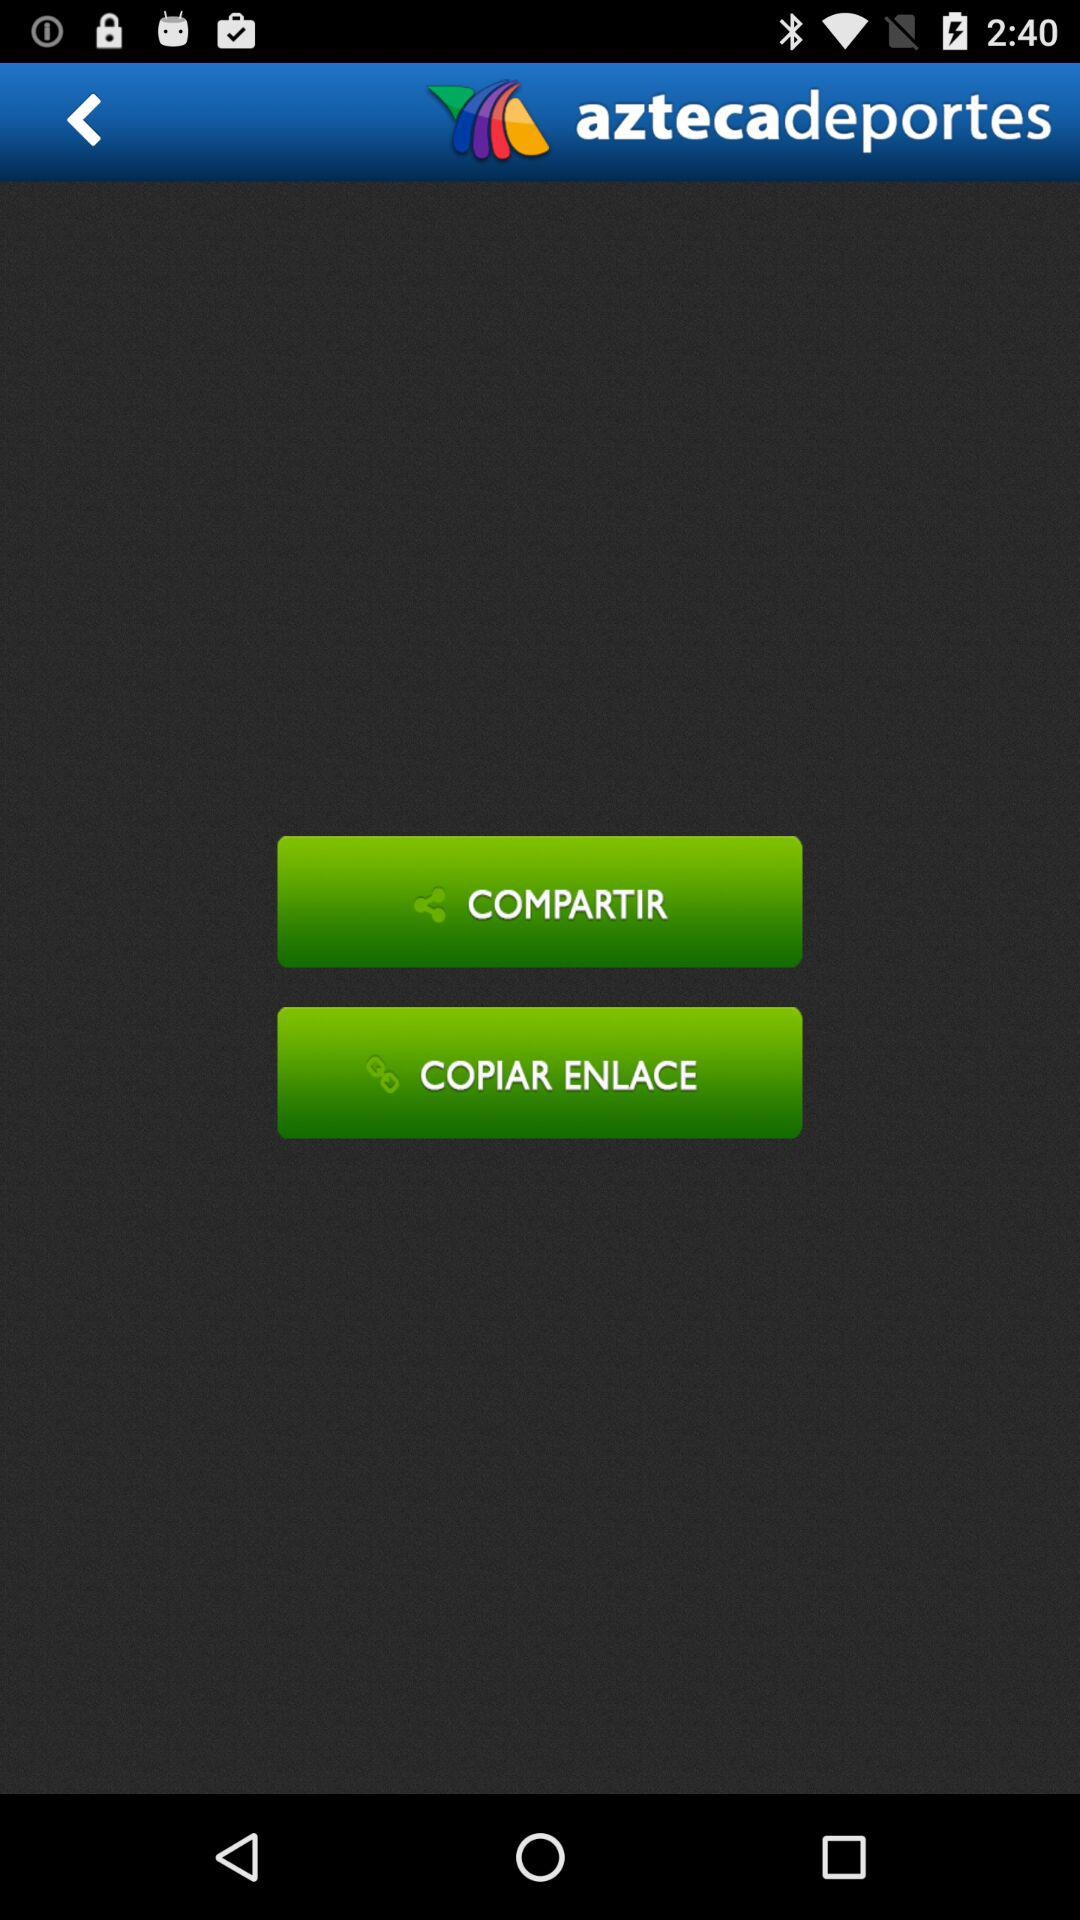What's the application name? The application name is "aztecadeportes". 